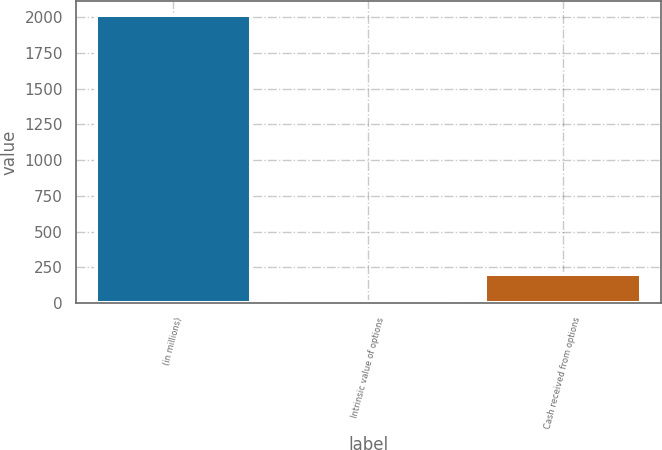Convert chart to OTSL. <chart><loc_0><loc_0><loc_500><loc_500><bar_chart><fcel>(in millions)<fcel>Intrinsic value of options<fcel>Cash received from options<nl><fcel>2015<fcel>5<fcel>206<nl></chart> 